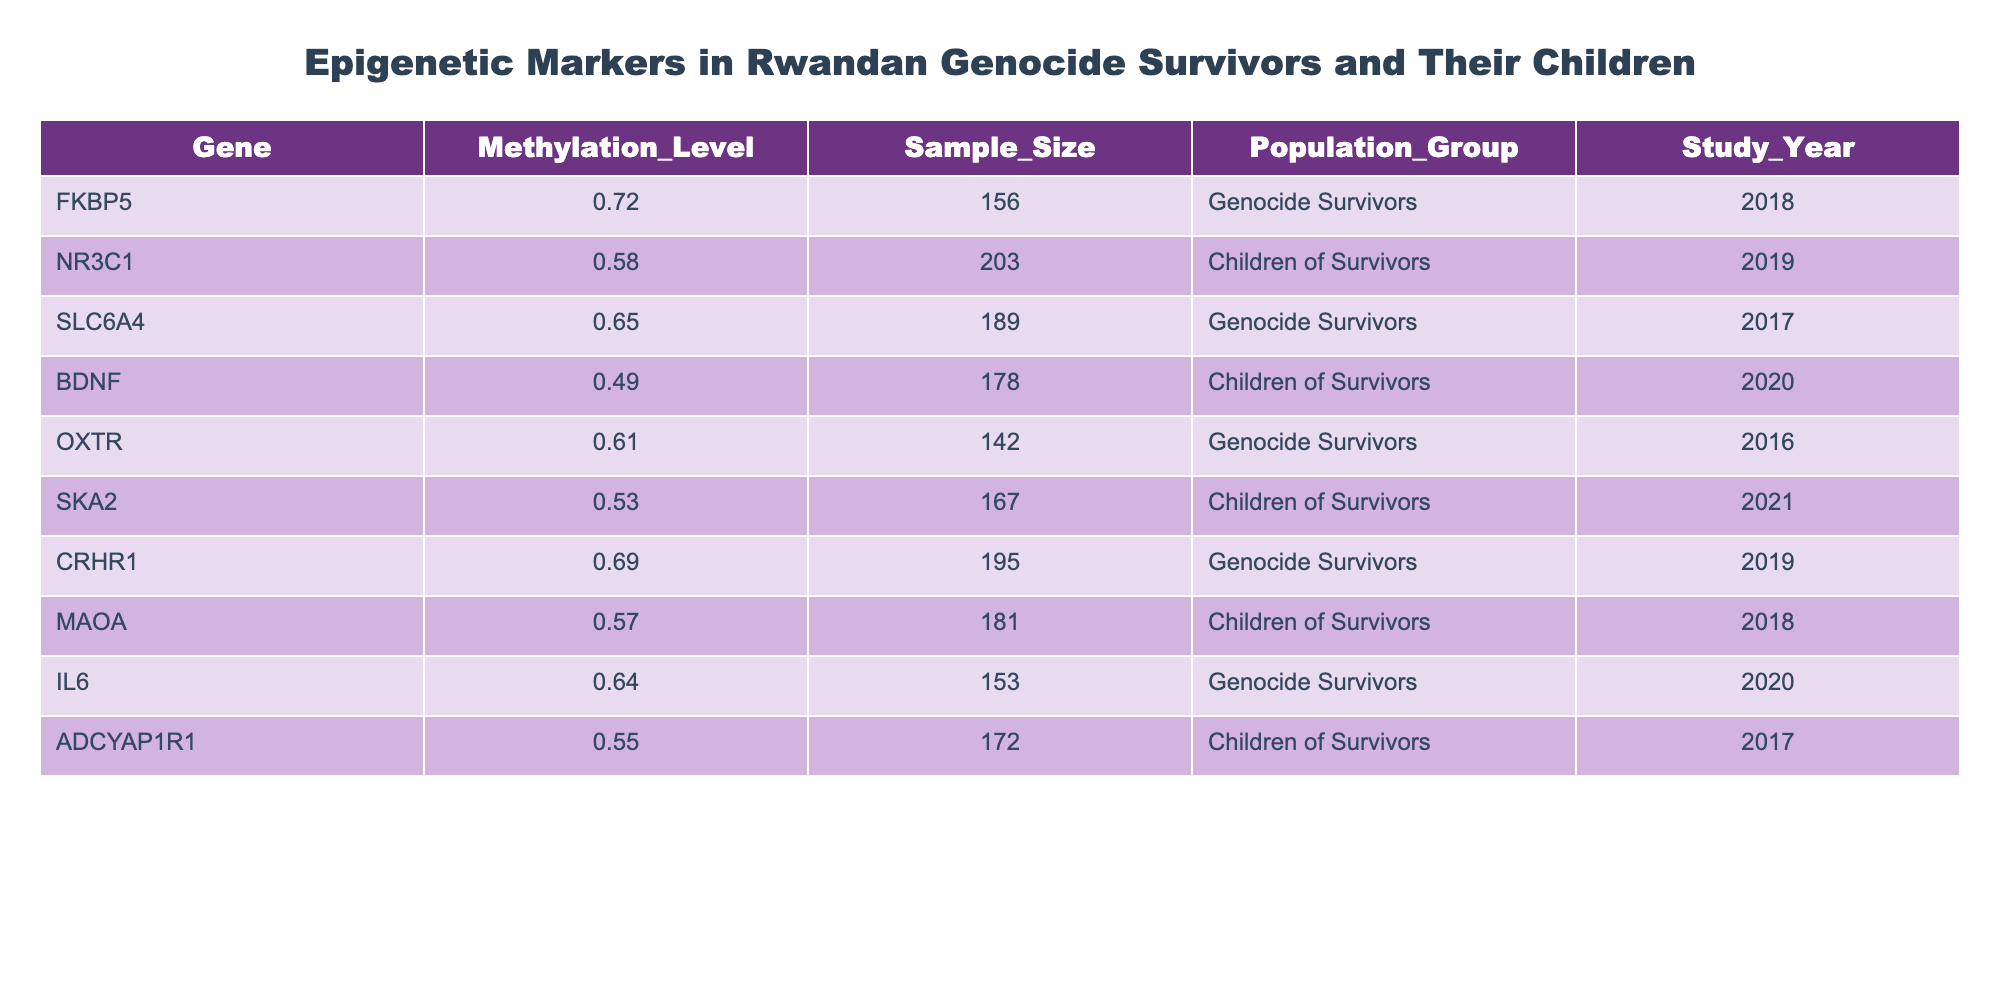What is the highest methylation level among the epigenetic markers listed? Upon examining the "Methylation_Level" column, the values are 0.72, 0.58, 0.65, 0.49, 0.61, 0.53, 0.69, 0.57, 0.64, and 0.55. The highest value is 0.72 associated with the gene FKBP5.
Answer: 0.72 How many samples were analyzed for the gene SLC6A4? Looking at the "Sample_Size" column corresponding to SLC6A4, it shows a value of 189.
Answer: 189 Which epigenetic marker has the lowest methylation level? Review the "Methylation_Level" column, the lowest value is 0.49, associated with the gene BDNF.
Answer: BDNF What is the average methylation level for the "Children of Survivors" group? The methylation levels for "Children of Survivors" are 0.58, 0.49, 0.53, 0.57, and 0.55. Summing these gives 2.72, and dividing by the number of values (5), the average is 0.544.
Answer: 0.544 Is there a gene that has a methylation level higher than 0.70? Checking the "Methylation_Level" column, FKBP5 has a level of 0.72, which confirms that there is a gene exceeding 0.70.
Answer: Yes How many genes have a methylation level above 0.60 in the "Genocide Survivors" group? Reviewing the data for "Genocide Survivors," the methylation levels above 0.60 are 0.72, 0.65, 0.61, 0.69, and 0.64. There are 5 such genes.
Answer: 5 What is the total sample size across all studies? Adding the sample sizes: 156 + 203 + 189 + 178 + 142 + 167 + 195 + 181 + 153 + 172 = 1937.
Answer: 1937 Which population group has the highest average methylation level? The values for "Genocide Survivors" are 0.72, 0.65, 0.61, 0.69, and 0.64 averaging 0.658. For "Children of Survivors," the average is 0.544. Therefore, "Genocide Survivors" has the highest average.
Answer: Genocide Survivors How does the methylation level of the gene MAOA compare to that of SLC6A4? The methylation level of MAOA is 0.57, while SLC6A4 is 0.65. Since 0.57 is less than 0.65, MAOA has a lower methylation level.
Answer: Lower How many genes are studied in total? Counting the entries in the table, there are 10 distinct genes listed.
Answer: 10 What is the difference in methylation levels between the genes CRHR1 and OXTR? The methylation level of CRHR1 is 0.69 and OXTR is 0.61. Subtracting gives 0.69 - 0.61 = 0.08.
Answer: 0.08 